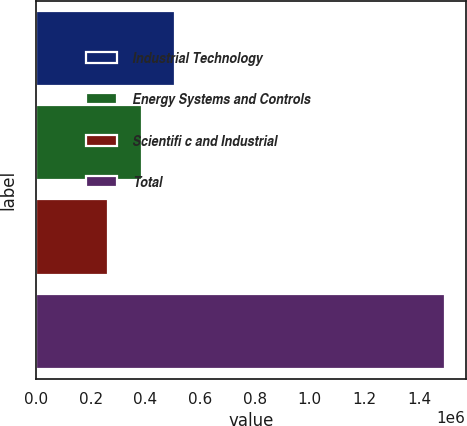Convert chart to OTSL. <chart><loc_0><loc_0><loc_500><loc_500><bar_chart><fcel>Industrial Technology<fcel>Energy Systems and Controls<fcel>Scientifi c and Industrial<fcel>Total<nl><fcel>509607<fcel>386473<fcel>263339<fcel>1.49468e+06<nl></chart> 